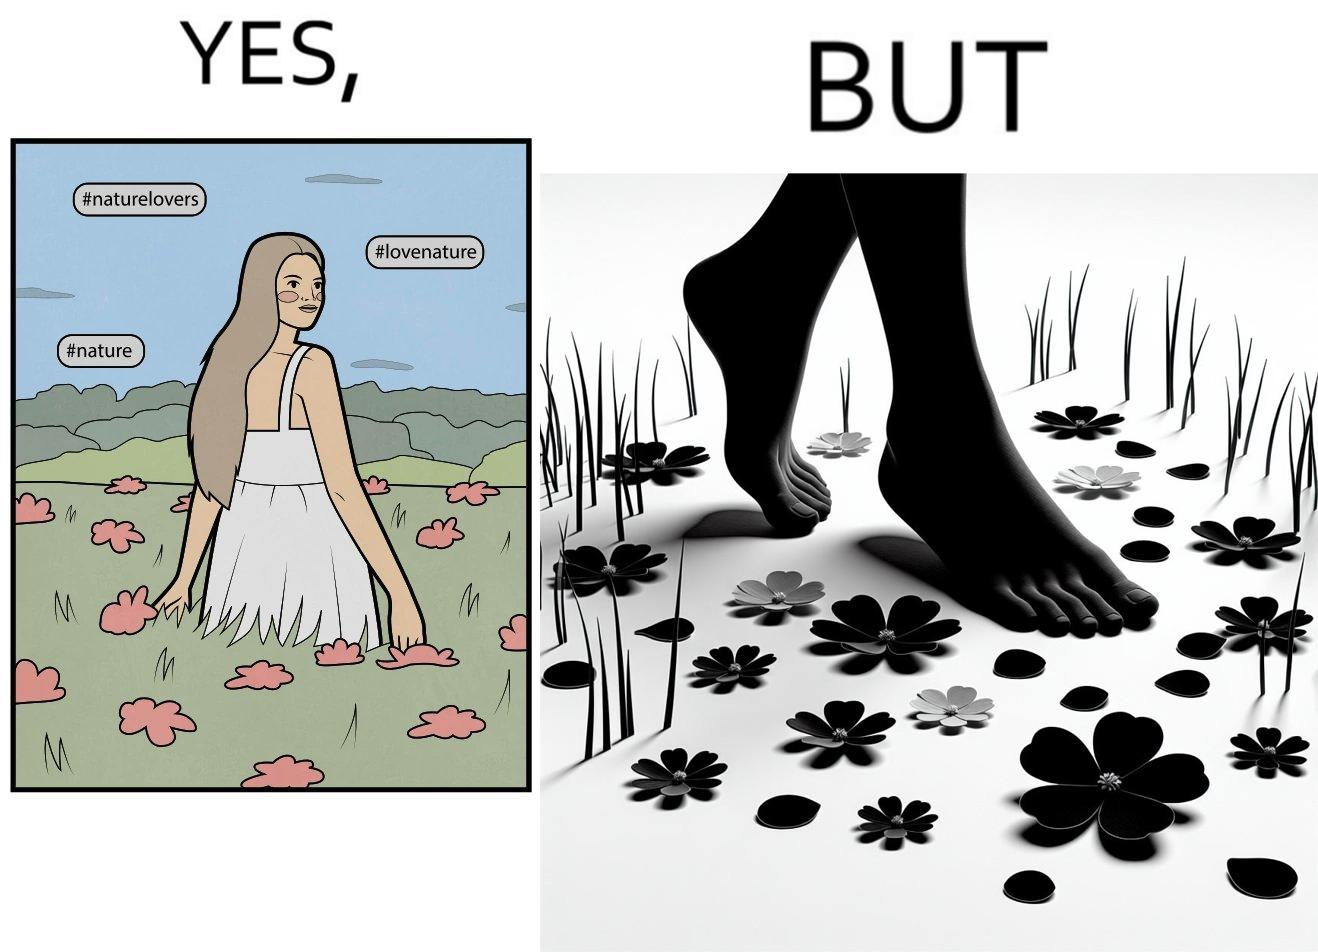Describe the content of this image. The image is ironical, as the social ,edia post shows the appreciation of nature, while an image of the feet on the ground stepping on the flower petals shows an unintentional disrespect of nature. 